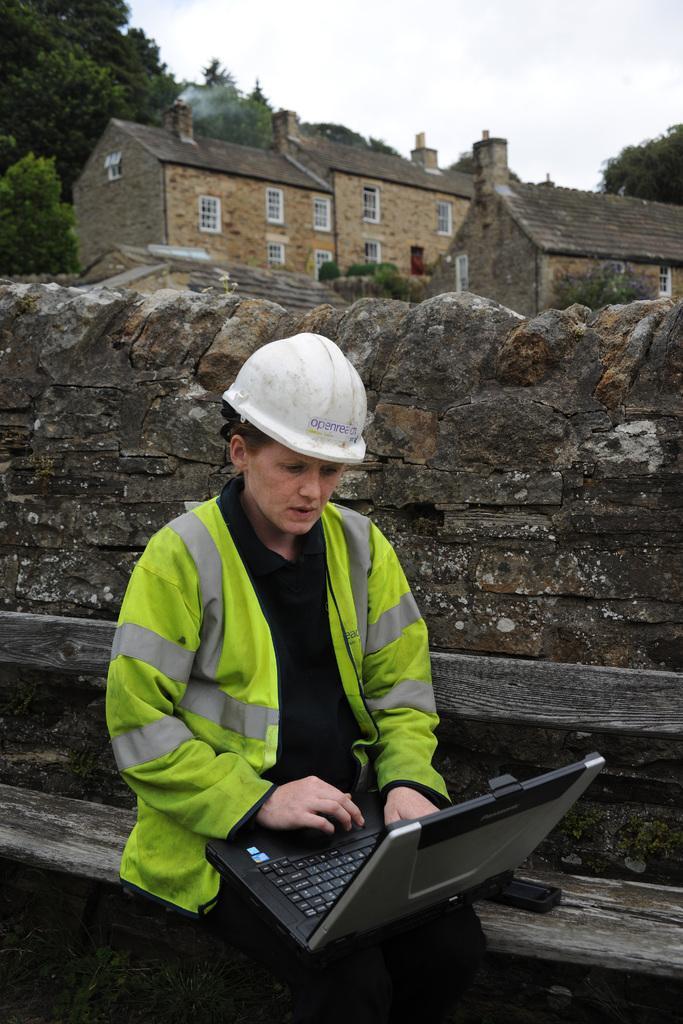Could you give a brief overview of what you see in this image? In the picture I can see a person wearing green color jacket and helmet is sitting on a wooden bench and using a laptop. In the background, we can see the stone wall, wooden houses, trees and the sky with clouds. 